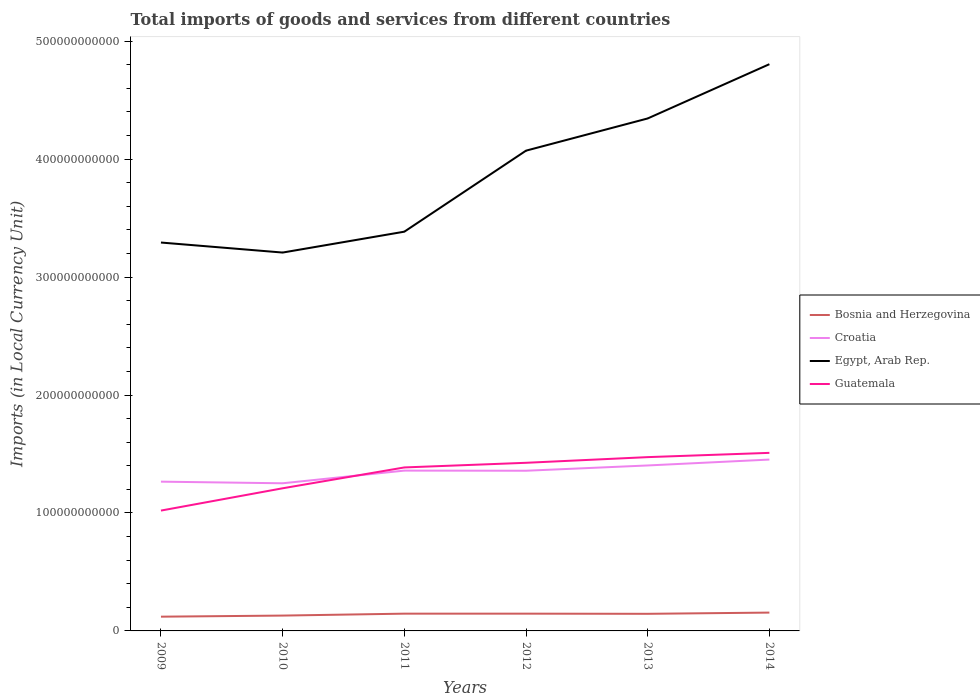How many different coloured lines are there?
Your answer should be compact. 4. Across all years, what is the maximum Amount of goods and services imports in Croatia?
Ensure brevity in your answer.  1.25e+11. In which year was the Amount of goods and services imports in Bosnia and Herzegovina maximum?
Make the answer very short. 2009. What is the total Amount of goods and services imports in Egypt, Arab Rep. in the graph?
Make the answer very short. -4.60e+1. What is the difference between the highest and the second highest Amount of goods and services imports in Bosnia and Herzegovina?
Ensure brevity in your answer.  3.45e+09. How many years are there in the graph?
Your answer should be compact. 6. What is the difference between two consecutive major ticks on the Y-axis?
Ensure brevity in your answer.  1.00e+11. Where does the legend appear in the graph?
Your response must be concise. Center right. How many legend labels are there?
Keep it short and to the point. 4. How are the legend labels stacked?
Provide a succinct answer. Vertical. What is the title of the graph?
Make the answer very short. Total imports of goods and services from different countries. Does "Czech Republic" appear as one of the legend labels in the graph?
Your response must be concise. No. What is the label or title of the X-axis?
Give a very brief answer. Years. What is the label or title of the Y-axis?
Your response must be concise. Imports (in Local Currency Unit). What is the Imports (in Local Currency Unit) of Bosnia and Herzegovina in 2009?
Make the answer very short. 1.21e+1. What is the Imports (in Local Currency Unit) of Croatia in 2009?
Give a very brief answer. 1.27e+11. What is the Imports (in Local Currency Unit) in Egypt, Arab Rep. in 2009?
Your response must be concise. 3.29e+11. What is the Imports (in Local Currency Unit) of Guatemala in 2009?
Your answer should be compact. 1.02e+11. What is the Imports (in Local Currency Unit) in Bosnia and Herzegovina in 2010?
Your answer should be very brief. 1.30e+1. What is the Imports (in Local Currency Unit) of Croatia in 2010?
Offer a terse response. 1.25e+11. What is the Imports (in Local Currency Unit) of Egypt, Arab Rep. in 2010?
Make the answer very short. 3.21e+11. What is the Imports (in Local Currency Unit) in Guatemala in 2010?
Provide a succinct answer. 1.21e+11. What is the Imports (in Local Currency Unit) in Bosnia and Herzegovina in 2011?
Your answer should be very brief. 1.46e+1. What is the Imports (in Local Currency Unit) in Croatia in 2011?
Keep it short and to the point. 1.36e+11. What is the Imports (in Local Currency Unit) of Egypt, Arab Rep. in 2011?
Your answer should be compact. 3.38e+11. What is the Imports (in Local Currency Unit) in Guatemala in 2011?
Provide a succinct answer. 1.39e+11. What is the Imports (in Local Currency Unit) in Bosnia and Herzegovina in 2012?
Your answer should be compact. 1.46e+1. What is the Imports (in Local Currency Unit) of Croatia in 2012?
Provide a succinct answer. 1.36e+11. What is the Imports (in Local Currency Unit) in Egypt, Arab Rep. in 2012?
Your answer should be very brief. 4.07e+11. What is the Imports (in Local Currency Unit) of Guatemala in 2012?
Provide a short and direct response. 1.43e+11. What is the Imports (in Local Currency Unit) of Bosnia and Herzegovina in 2013?
Your response must be concise. 1.45e+1. What is the Imports (in Local Currency Unit) of Croatia in 2013?
Provide a short and direct response. 1.40e+11. What is the Imports (in Local Currency Unit) of Egypt, Arab Rep. in 2013?
Keep it short and to the point. 4.34e+11. What is the Imports (in Local Currency Unit) in Guatemala in 2013?
Your answer should be very brief. 1.47e+11. What is the Imports (in Local Currency Unit) in Bosnia and Herzegovina in 2014?
Your answer should be very brief. 1.55e+1. What is the Imports (in Local Currency Unit) of Croatia in 2014?
Keep it short and to the point. 1.45e+11. What is the Imports (in Local Currency Unit) of Egypt, Arab Rep. in 2014?
Ensure brevity in your answer.  4.80e+11. What is the Imports (in Local Currency Unit) in Guatemala in 2014?
Provide a succinct answer. 1.51e+11. Across all years, what is the maximum Imports (in Local Currency Unit) of Bosnia and Herzegovina?
Offer a terse response. 1.55e+1. Across all years, what is the maximum Imports (in Local Currency Unit) of Croatia?
Your response must be concise. 1.45e+11. Across all years, what is the maximum Imports (in Local Currency Unit) of Egypt, Arab Rep.?
Ensure brevity in your answer.  4.80e+11. Across all years, what is the maximum Imports (in Local Currency Unit) of Guatemala?
Offer a terse response. 1.51e+11. Across all years, what is the minimum Imports (in Local Currency Unit) in Bosnia and Herzegovina?
Your answer should be compact. 1.21e+1. Across all years, what is the minimum Imports (in Local Currency Unit) in Croatia?
Give a very brief answer. 1.25e+11. Across all years, what is the minimum Imports (in Local Currency Unit) in Egypt, Arab Rep.?
Make the answer very short. 3.21e+11. Across all years, what is the minimum Imports (in Local Currency Unit) of Guatemala?
Make the answer very short. 1.02e+11. What is the total Imports (in Local Currency Unit) of Bosnia and Herzegovina in the graph?
Offer a very short reply. 8.44e+1. What is the total Imports (in Local Currency Unit) of Croatia in the graph?
Ensure brevity in your answer.  8.09e+11. What is the total Imports (in Local Currency Unit) in Egypt, Arab Rep. in the graph?
Give a very brief answer. 2.31e+12. What is the total Imports (in Local Currency Unit) in Guatemala in the graph?
Your response must be concise. 8.02e+11. What is the difference between the Imports (in Local Currency Unit) in Bosnia and Herzegovina in 2009 and that in 2010?
Ensure brevity in your answer.  -9.19e+08. What is the difference between the Imports (in Local Currency Unit) in Croatia in 2009 and that in 2010?
Provide a short and direct response. 1.38e+09. What is the difference between the Imports (in Local Currency Unit) of Egypt, Arab Rep. in 2009 and that in 2010?
Provide a short and direct response. 8.50e+09. What is the difference between the Imports (in Local Currency Unit) in Guatemala in 2009 and that in 2010?
Keep it short and to the point. -1.89e+1. What is the difference between the Imports (in Local Currency Unit) in Bosnia and Herzegovina in 2009 and that in 2011?
Provide a succinct answer. -2.55e+09. What is the difference between the Imports (in Local Currency Unit) of Croatia in 2009 and that in 2011?
Your answer should be compact. -9.36e+09. What is the difference between the Imports (in Local Currency Unit) of Egypt, Arab Rep. in 2009 and that in 2011?
Your response must be concise. -9.20e+09. What is the difference between the Imports (in Local Currency Unit) of Guatemala in 2009 and that in 2011?
Make the answer very short. -3.66e+1. What is the difference between the Imports (in Local Currency Unit) in Bosnia and Herzegovina in 2009 and that in 2012?
Offer a very short reply. -2.55e+09. What is the difference between the Imports (in Local Currency Unit) of Croatia in 2009 and that in 2012?
Provide a succinct answer. -9.27e+09. What is the difference between the Imports (in Local Currency Unit) of Egypt, Arab Rep. in 2009 and that in 2012?
Your response must be concise. -7.79e+1. What is the difference between the Imports (in Local Currency Unit) of Guatemala in 2009 and that in 2012?
Provide a succinct answer. -4.05e+1. What is the difference between the Imports (in Local Currency Unit) in Bosnia and Herzegovina in 2009 and that in 2013?
Provide a succinct answer. -2.42e+09. What is the difference between the Imports (in Local Currency Unit) in Croatia in 2009 and that in 2013?
Offer a very short reply. -1.37e+1. What is the difference between the Imports (in Local Currency Unit) of Egypt, Arab Rep. in 2009 and that in 2013?
Provide a succinct answer. -1.05e+11. What is the difference between the Imports (in Local Currency Unit) in Guatemala in 2009 and that in 2013?
Ensure brevity in your answer.  -4.53e+1. What is the difference between the Imports (in Local Currency Unit) of Bosnia and Herzegovina in 2009 and that in 2014?
Your answer should be very brief. -3.45e+09. What is the difference between the Imports (in Local Currency Unit) in Croatia in 2009 and that in 2014?
Give a very brief answer. -1.87e+1. What is the difference between the Imports (in Local Currency Unit) of Egypt, Arab Rep. in 2009 and that in 2014?
Provide a short and direct response. -1.51e+11. What is the difference between the Imports (in Local Currency Unit) of Guatemala in 2009 and that in 2014?
Make the answer very short. -4.89e+1. What is the difference between the Imports (in Local Currency Unit) of Bosnia and Herzegovina in 2010 and that in 2011?
Offer a terse response. -1.63e+09. What is the difference between the Imports (in Local Currency Unit) of Croatia in 2010 and that in 2011?
Your answer should be very brief. -1.07e+1. What is the difference between the Imports (in Local Currency Unit) of Egypt, Arab Rep. in 2010 and that in 2011?
Ensure brevity in your answer.  -1.77e+1. What is the difference between the Imports (in Local Currency Unit) of Guatemala in 2010 and that in 2011?
Your answer should be compact. -1.77e+1. What is the difference between the Imports (in Local Currency Unit) of Bosnia and Herzegovina in 2010 and that in 2012?
Ensure brevity in your answer.  -1.63e+09. What is the difference between the Imports (in Local Currency Unit) in Croatia in 2010 and that in 2012?
Offer a terse response. -1.06e+1. What is the difference between the Imports (in Local Currency Unit) in Egypt, Arab Rep. in 2010 and that in 2012?
Provide a succinct answer. -8.64e+1. What is the difference between the Imports (in Local Currency Unit) in Guatemala in 2010 and that in 2012?
Offer a very short reply. -2.16e+1. What is the difference between the Imports (in Local Currency Unit) of Bosnia and Herzegovina in 2010 and that in 2013?
Your answer should be compact. -1.50e+09. What is the difference between the Imports (in Local Currency Unit) of Croatia in 2010 and that in 2013?
Offer a very short reply. -1.51e+1. What is the difference between the Imports (in Local Currency Unit) of Egypt, Arab Rep. in 2010 and that in 2013?
Offer a terse response. -1.14e+11. What is the difference between the Imports (in Local Currency Unit) in Guatemala in 2010 and that in 2013?
Offer a terse response. -2.64e+1. What is the difference between the Imports (in Local Currency Unit) in Bosnia and Herzegovina in 2010 and that in 2014?
Provide a short and direct response. -2.53e+09. What is the difference between the Imports (in Local Currency Unit) of Croatia in 2010 and that in 2014?
Ensure brevity in your answer.  -2.01e+1. What is the difference between the Imports (in Local Currency Unit) of Egypt, Arab Rep. in 2010 and that in 2014?
Offer a terse response. -1.60e+11. What is the difference between the Imports (in Local Currency Unit) of Guatemala in 2010 and that in 2014?
Make the answer very short. -3.00e+1. What is the difference between the Imports (in Local Currency Unit) in Bosnia and Herzegovina in 2011 and that in 2012?
Provide a succinct answer. 1.75e+06. What is the difference between the Imports (in Local Currency Unit) of Croatia in 2011 and that in 2012?
Your response must be concise. 9.93e+07. What is the difference between the Imports (in Local Currency Unit) in Egypt, Arab Rep. in 2011 and that in 2012?
Keep it short and to the point. -6.87e+1. What is the difference between the Imports (in Local Currency Unit) of Guatemala in 2011 and that in 2012?
Offer a very short reply. -3.94e+09. What is the difference between the Imports (in Local Currency Unit) in Bosnia and Herzegovina in 2011 and that in 2013?
Your answer should be very brief. 1.36e+08. What is the difference between the Imports (in Local Currency Unit) of Croatia in 2011 and that in 2013?
Your answer should be very brief. -4.37e+09. What is the difference between the Imports (in Local Currency Unit) of Egypt, Arab Rep. in 2011 and that in 2013?
Your answer should be compact. -9.60e+1. What is the difference between the Imports (in Local Currency Unit) of Guatemala in 2011 and that in 2013?
Your response must be concise. -8.75e+09. What is the difference between the Imports (in Local Currency Unit) of Bosnia and Herzegovina in 2011 and that in 2014?
Offer a very short reply. -8.99e+08. What is the difference between the Imports (in Local Currency Unit) in Croatia in 2011 and that in 2014?
Offer a terse response. -9.36e+09. What is the difference between the Imports (in Local Currency Unit) of Egypt, Arab Rep. in 2011 and that in 2014?
Provide a short and direct response. -1.42e+11. What is the difference between the Imports (in Local Currency Unit) in Guatemala in 2011 and that in 2014?
Your answer should be compact. -1.24e+1. What is the difference between the Imports (in Local Currency Unit) in Bosnia and Herzegovina in 2012 and that in 2013?
Keep it short and to the point. 1.34e+08. What is the difference between the Imports (in Local Currency Unit) in Croatia in 2012 and that in 2013?
Provide a short and direct response. -4.47e+09. What is the difference between the Imports (in Local Currency Unit) of Egypt, Arab Rep. in 2012 and that in 2013?
Your response must be concise. -2.73e+1. What is the difference between the Imports (in Local Currency Unit) in Guatemala in 2012 and that in 2013?
Keep it short and to the point. -4.81e+09. What is the difference between the Imports (in Local Currency Unit) of Bosnia and Herzegovina in 2012 and that in 2014?
Give a very brief answer. -9.01e+08. What is the difference between the Imports (in Local Currency Unit) in Croatia in 2012 and that in 2014?
Ensure brevity in your answer.  -9.46e+09. What is the difference between the Imports (in Local Currency Unit) of Egypt, Arab Rep. in 2012 and that in 2014?
Make the answer very short. -7.33e+1. What is the difference between the Imports (in Local Currency Unit) of Guatemala in 2012 and that in 2014?
Ensure brevity in your answer.  -8.42e+09. What is the difference between the Imports (in Local Currency Unit) in Bosnia and Herzegovina in 2013 and that in 2014?
Give a very brief answer. -1.03e+09. What is the difference between the Imports (in Local Currency Unit) in Croatia in 2013 and that in 2014?
Make the answer very short. -5.00e+09. What is the difference between the Imports (in Local Currency Unit) of Egypt, Arab Rep. in 2013 and that in 2014?
Provide a succinct answer. -4.60e+1. What is the difference between the Imports (in Local Currency Unit) of Guatemala in 2013 and that in 2014?
Offer a very short reply. -3.61e+09. What is the difference between the Imports (in Local Currency Unit) of Bosnia and Herzegovina in 2009 and the Imports (in Local Currency Unit) of Croatia in 2010?
Your answer should be compact. -1.13e+11. What is the difference between the Imports (in Local Currency Unit) of Bosnia and Herzegovina in 2009 and the Imports (in Local Currency Unit) of Egypt, Arab Rep. in 2010?
Offer a terse response. -3.09e+11. What is the difference between the Imports (in Local Currency Unit) of Bosnia and Herzegovina in 2009 and the Imports (in Local Currency Unit) of Guatemala in 2010?
Provide a short and direct response. -1.09e+11. What is the difference between the Imports (in Local Currency Unit) of Croatia in 2009 and the Imports (in Local Currency Unit) of Egypt, Arab Rep. in 2010?
Provide a short and direct response. -1.94e+11. What is the difference between the Imports (in Local Currency Unit) in Croatia in 2009 and the Imports (in Local Currency Unit) in Guatemala in 2010?
Make the answer very short. 5.61e+09. What is the difference between the Imports (in Local Currency Unit) of Egypt, Arab Rep. in 2009 and the Imports (in Local Currency Unit) of Guatemala in 2010?
Keep it short and to the point. 2.08e+11. What is the difference between the Imports (in Local Currency Unit) of Bosnia and Herzegovina in 2009 and the Imports (in Local Currency Unit) of Croatia in 2011?
Your answer should be very brief. -1.24e+11. What is the difference between the Imports (in Local Currency Unit) in Bosnia and Herzegovina in 2009 and the Imports (in Local Currency Unit) in Egypt, Arab Rep. in 2011?
Your answer should be very brief. -3.26e+11. What is the difference between the Imports (in Local Currency Unit) of Bosnia and Herzegovina in 2009 and the Imports (in Local Currency Unit) of Guatemala in 2011?
Offer a terse response. -1.27e+11. What is the difference between the Imports (in Local Currency Unit) in Croatia in 2009 and the Imports (in Local Currency Unit) in Egypt, Arab Rep. in 2011?
Make the answer very short. -2.12e+11. What is the difference between the Imports (in Local Currency Unit) in Croatia in 2009 and the Imports (in Local Currency Unit) in Guatemala in 2011?
Your answer should be compact. -1.20e+1. What is the difference between the Imports (in Local Currency Unit) of Egypt, Arab Rep. in 2009 and the Imports (in Local Currency Unit) of Guatemala in 2011?
Offer a terse response. 1.91e+11. What is the difference between the Imports (in Local Currency Unit) of Bosnia and Herzegovina in 2009 and the Imports (in Local Currency Unit) of Croatia in 2012?
Make the answer very short. -1.24e+11. What is the difference between the Imports (in Local Currency Unit) in Bosnia and Herzegovina in 2009 and the Imports (in Local Currency Unit) in Egypt, Arab Rep. in 2012?
Your answer should be very brief. -3.95e+11. What is the difference between the Imports (in Local Currency Unit) in Bosnia and Herzegovina in 2009 and the Imports (in Local Currency Unit) in Guatemala in 2012?
Provide a short and direct response. -1.30e+11. What is the difference between the Imports (in Local Currency Unit) in Croatia in 2009 and the Imports (in Local Currency Unit) in Egypt, Arab Rep. in 2012?
Give a very brief answer. -2.81e+11. What is the difference between the Imports (in Local Currency Unit) of Croatia in 2009 and the Imports (in Local Currency Unit) of Guatemala in 2012?
Make the answer very short. -1.60e+1. What is the difference between the Imports (in Local Currency Unit) in Egypt, Arab Rep. in 2009 and the Imports (in Local Currency Unit) in Guatemala in 2012?
Your answer should be compact. 1.87e+11. What is the difference between the Imports (in Local Currency Unit) in Bosnia and Herzegovina in 2009 and the Imports (in Local Currency Unit) in Croatia in 2013?
Your response must be concise. -1.28e+11. What is the difference between the Imports (in Local Currency Unit) in Bosnia and Herzegovina in 2009 and the Imports (in Local Currency Unit) in Egypt, Arab Rep. in 2013?
Offer a terse response. -4.22e+11. What is the difference between the Imports (in Local Currency Unit) in Bosnia and Herzegovina in 2009 and the Imports (in Local Currency Unit) in Guatemala in 2013?
Your response must be concise. -1.35e+11. What is the difference between the Imports (in Local Currency Unit) of Croatia in 2009 and the Imports (in Local Currency Unit) of Egypt, Arab Rep. in 2013?
Offer a very short reply. -3.08e+11. What is the difference between the Imports (in Local Currency Unit) in Croatia in 2009 and the Imports (in Local Currency Unit) in Guatemala in 2013?
Keep it short and to the point. -2.08e+1. What is the difference between the Imports (in Local Currency Unit) in Egypt, Arab Rep. in 2009 and the Imports (in Local Currency Unit) in Guatemala in 2013?
Your response must be concise. 1.82e+11. What is the difference between the Imports (in Local Currency Unit) of Bosnia and Herzegovina in 2009 and the Imports (in Local Currency Unit) of Croatia in 2014?
Your response must be concise. -1.33e+11. What is the difference between the Imports (in Local Currency Unit) of Bosnia and Herzegovina in 2009 and the Imports (in Local Currency Unit) of Egypt, Arab Rep. in 2014?
Your answer should be very brief. -4.68e+11. What is the difference between the Imports (in Local Currency Unit) of Bosnia and Herzegovina in 2009 and the Imports (in Local Currency Unit) of Guatemala in 2014?
Make the answer very short. -1.39e+11. What is the difference between the Imports (in Local Currency Unit) in Croatia in 2009 and the Imports (in Local Currency Unit) in Egypt, Arab Rep. in 2014?
Offer a very short reply. -3.54e+11. What is the difference between the Imports (in Local Currency Unit) of Croatia in 2009 and the Imports (in Local Currency Unit) of Guatemala in 2014?
Keep it short and to the point. -2.44e+1. What is the difference between the Imports (in Local Currency Unit) in Egypt, Arab Rep. in 2009 and the Imports (in Local Currency Unit) in Guatemala in 2014?
Keep it short and to the point. 1.78e+11. What is the difference between the Imports (in Local Currency Unit) of Bosnia and Herzegovina in 2010 and the Imports (in Local Currency Unit) of Croatia in 2011?
Provide a short and direct response. -1.23e+11. What is the difference between the Imports (in Local Currency Unit) in Bosnia and Herzegovina in 2010 and the Imports (in Local Currency Unit) in Egypt, Arab Rep. in 2011?
Provide a short and direct response. -3.25e+11. What is the difference between the Imports (in Local Currency Unit) in Bosnia and Herzegovina in 2010 and the Imports (in Local Currency Unit) in Guatemala in 2011?
Keep it short and to the point. -1.26e+11. What is the difference between the Imports (in Local Currency Unit) in Croatia in 2010 and the Imports (in Local Currency Unit) in Egypt, Arab Rep. in 2011?
Provide a short and direct response. -2.13e+11. What is the difference between the Imports (in Local Currency Unit) in Croatia in 2010 and the Imports (in Local Currency Unit) in Guatemala in 2011?
Your answer should be very brief. -1.34e+1. What is the difference between the Imports (in Local Currency Unit) of Egypt, Arab Rep. in 2010 and the Imports (in Local Currency Unit) of Guatemala in 2011?
Offer a very short reply. 1.82e+11. What is the difference between the Imports (in Local Currency Unit) of Bosnia and Herzegovina in 2010 and the Imports (in Local Currency Unit) of Croatia in 2012?
Ensure brevity in your answer.  -1.23e+11. What is the difference between the Imports (in Local Currency Unit) of Bosnia and Herzegovina in 2010 and the Imports (in Local Currency Unit) of Egypt, Arab Rep. in 2012?
Ensure brevity in your answer.  -3.94e+11. What is the difference between the Imports (in Local Currency Unit) in Bosnia and Herzegovina in 2010 and the Imports (in Local Currency Unit) in Guatemala in 2012?
Offer a very short reply. -1.30e+11. What is the difference between the Imports (in Local Currency Unit) in Croatia in 2010 and the Imports (in Local Currency Unit) in Egypt, Arab Rep. in 2012?
Ensure brevity in your answer.  -2.82e+11. What is the difference between the Imports (in Local Currency Unit) of Croatia in 2010 and the Imports (in Local Currency Unit) of Guatemala in 2012?
Give a very brief answer. -1.74e+1. What is the difference between the Imports (in Local Currency Unit) of Egypt, Arab Rep. in 2010 and the Imports (in Local Currency Unit) of Guatemala in 2012?
Provide a short and direct response. 1.78e+11. What is the difference between the Imports (in Local Currency Unit) in Bosnia and Herzegovina in 2010 and the Imports (in Local Currency Unit) in Croatia in 2013?
Keep it short and to the point. -1.27e+11. What is the difference between the Imports (in Local Currency Unit) of Bosnia and Herzegovina in 2010 and the Imports (in Local Currency Unit) of Egypt, Arab Rep. in 2013?
Your answer should be very brief. -4.21e+11. What is the difference between the Imports (in Local Currency Unit) in Bosnia and Herzegovina in 2010 and the Imports (in Local Currency Unit) in Guatemala in 2013?
Make the answer very short. -1.34e+11. What is the difference between the Imports (in Local Currency Unit) in Croatia in 2010 and the Imports (in Local Currency Unit) in Egypt, Arab Rep. in 2013?
Provide a short and direct response. -3.09e+11. What is the difference between the Imports (in Local Currency Unit) of Croatia in 2010 and the Imports (in Local Currency Unit) of Guatemala in 2013?
Ensure brevity in your answer.  -2.22e+1. What is the difference between the Imports (in Local Currency Unit) of Egypt, Arab Rep. in 2010 and the Imports (in Local Currency Unit) of Guatemala in 2013?
Make the answer very short. 1.73e+11. What is the difference between the Imports (in Local Currency Unit) in Bosnia and Herzegovina in 2010 and the Imports (in Local Currency Unit) in Croatia in 2014?
Make the answer very short. -1.32e+11. What is the difference between the Imports (in Local Currency Unit) of Bosnia and Herzegovina in 2010 and the Imports (in Local Currency Unit) of Egypt, Arab Rep. in 2014?
Keep it short and to the point. -4.67e+11. What is the difference between the Imports (in Local Currency Unit) in Bosnia and Herzegovina in 2010 and the Imports (in Local Currency Unit) in Guatemala in 2014?
Give a very brief answer. -1.38e+11. What is the difference between the Imports (in Local Currency Unit) of Croatia in 2010 and the Imports (in Local Currency Unit) of Egypt, Arab Rep. in 2014?
Ensure brevity in your answer.  -3.55e+11. What is the difference between the Imports (in Local Currency Unit) in Croatia in 2010 and the Imports (in Local Currency Unit) in Guatemala in 2014?
Offer a very short reply. -2.58e+1. What is the difference between the Imports (in Local Currency Unit) in Egypt, Arab Rep. in 2010 and the Imports (in Local Currency Unit) in Guatemala in 2014?
Your response must be concise. 1.70e+11. What is the difference between the Imports (in Local Currency Unit) in Bosnia and Herzegovina in 2011 and the Imports (in Local Currency Unit) in Croatia in 2012?
Provide a succinct answer. -1.21e+11. What is the difference between the Imports (in Local Currency Unit) in Bosnia and Herzegovina in 2011 and the Imports (in Local Currency Unit) in Egypt, Arab Rep. in 2012?
Make the answer very short. -3.93e+11. What is the difference between the Imports (in Local Currency Unit) in Bosnia and Herzegovina in 2011 and the Imports (in Local Currency Unit) in Guatemala in 2012?
Make the answer very short. -1.28e+11. What is the difference between the Imports (in Local Currency Unit) of Croatia in 2011 and the Imports (in Local Currency Unit) of Egypt, Arab Rep. in 2012?
Your answer should be very brief. -2.71e+11. What is the difference between the Imports (in Local Currency Unit) in Croatia in 2011 and the Imports (in Local Currency Unit) in Guatemala in 2012?
Your answer should be compact. -6.63e+09. What is the difference between the Imports (in Local Currency Unit) of Egypt, Arab Rep. in 2011 and the Imports (in Local Currency Unit) of Guatemala in 2012?
Keep it short and to the point. 1.96e+11. What is the difference between the Imports (in Local Currency Unit) of Bosnia and Herzegovina in 2011 and the Imports (in Local Currency Unit) of Croatia in 2013?
Keep it short and to the point. -1.26e+11. What is the difference between the Imports (in Local Currency Unit) of Bosnia and Herzegovina in 2011 and the Imports (in Local Currency Unit) of Egypt, Arab Rep. in 2013?
Ensure brevity in your answer.  -4.20e+11. What is the difference between the Imports (in Local Currency Unit) in Bosnia and Herzegovina in 2011 and the Imports (in Local Currency Unit) in Guatemala in 2013?
Your response must be concise. -1.33e+11. What is the difference between the Imports (in Local Currency Unit) in Croatia in 2011 and the Imports (in Local Currency Unit) in Egypt, Arab Rep. in 2013?
Ensure brevity in your answer.  -2.99e+11. What is the difference between the Imports (in Local Currency Unit) in Croatia in 2011 and the Imports (in Local Currency Unit) in Guatemala in 2013?
Keep it short and to the point. -1.14e+1. What is the difference between the Imports (in Local Currency Unit) of Egypt, Arab Rep. in 2011 and the Imports (in Local Currency Unit) of Guatemala in 2013?
Your answer should be compact. 1.91e+11. What is the difference between the Imports (in Local Currency Unit) of Bosnia and Herzegovina in 2011 and the Imports (in Local Currency Unit) of Croatia in 2014?
Your response must be concise. -1.31e+11. What is the difference between the Imports (in Local Currency Unit) in Bosnia and Herzegovina in 2011 and the Imports (in Local Currency Unit) in Egypt, Arab Rep. in 2014?
Offer a terse response. -4.66e+11. What is the difference between the Imports (in Local Currency Unit) in Bosnia and Herzegovina in 2011 and the Imports (in Local Currency Unit) in Guatemala in 2014?
Provide a succinct answer. -1.36e+11. What is the difference between the Imports (in Local Currency Unit) of Croatia in 2011 and the Imports (in Local Currency Unit) of Egypt, Arab Rep. in 2014?
Your answer should be compact. -3.45e+11. What is the difference between the Imports (in Local Currency Unit) of Croatia in 2011 and the Imports (in Local Currency Unit) of Guatemala in 2014?
Offer a terse response. -1.50e+1. What is the difference between the Imports (in Local Currency Unit) of Egypt, Arab Rep. in 2011 and the Imports (in Local Currency Unit) of Guatemala in 2014?
Your answer should be compact. 1.88e+11. What is the difference between the Imports (in Local Currency Unit) of Bosnia and Herzegovina in 2012 and the Imports (in Local Currency Unit) of Croatia in 2013?
Keep it short and to the point. -1.26e+11. What is the difference between the Imports (in Local Currency Unit) in Bosnia and Herzegovina in 2012 and the Imports (in Local Currency Unit) in Egypt, Arab Rep. in 2013?
Your response must be concise. -4.20e+11. What is the difference between the Imports (in Local Currency Unit) in Bosnia and Herzegovina in 2012 and the Imports (in Local Currency Unit) in Guatemala in 2013?
Your response must be concise. -1.33e+11. What is the difference between the Imports (in Local Currency Unit) in Croatia in 2012 and the Imports (in Local Currency Unit) in Egypt, Arab Rep. in 2013?
Make the answer very short. -2.99e+11. What is the difference between the Imports (in Local Currency Unit) of Croatia in 2012 and the Imports (in Local Currency Unit) of Guatemala in 2013?
Make the answer very short. -1.15e+1. What is the difference between the Imports (in Local Currency Unit) of Egypt, Arab Rep. in 2012 and the Imports (in Local Currency Unit) of Guatemala in 2013?
Provide a short and direct response. 2.60e+11. What is the difference between the Imports (in Local Currency Unit) in Bosnia and Herzegovina in 2012 and the Imports (in Local Currency Unit) in Croatia in 2014?
Your response must be concise. -1.31e+11. What is the difference between the Imports (in Local Currency Unit) of Bosnia and Herzegovina in 2012 and the Imports (in Local Currency Unit) of Egypt, Arab Rep. in 2014?
Your answer should be very brief. -4.66e+11. What is the difference between the Imports (in Local Currency Unit) in Bosnia and Herzegovina in 2012 and the Imports (in Local Currency Unit) in Guatemala in 2014?
Give a very brief answer. -1.36e+11. What is the difference between the Imports (in Local Currency Unit) of Croatia in 2012 and the Imports (in Local Currency Unit) of Egypt, Arab Rep. in 2014?
Provide a short and direct response. -3.45e+11. What is the difference between the Imports (in Local Currency Unit) of Croatia in 2012 and the Imports (in Local Currency Unit) of Guatemala in 2014?
Give a very brief answer. -1.51e+1. What is the difference between the Imports (in Local Currency Unit) of Egypt, Arab Rep. in 2012 and the Imports (in Local Currency Unit) of Guatemala in 2014?
Offer a terse response. 2.56e+11. What is the difference between the Imports (in Local Currency Unit) in Bosnia and Herzegovina in 2013 and the Imports (in Local Currency Unit) in Croatia in 2014?
Keep it short and to the point. -1.31e+11. What is the difference between the Imports (in Local Currency Unit) in Bosnia and Herzegovina in 2013 and the Imports (in Local Currency Unit) in Egypt, Arab Rep. in 2014?
Your response must be concise. -4.66e+11. What is the difference between the Imports (in Local Currency Unit) of Bosnia and Herzegovina in 2013 and the Imports (in Local Currency Unit) of Guatemala in 2014?
Keep it short and to the point. -1.36e+11. What is the difference between the Imports (in Local Currency Unit) of Croatia in 2013 and the Imports (in Local Currency Unit) of Egypt, Arab Rep. in 2014?
Give a very brief answer. -3.40e+11. What is the difference between the Imports (in Local Currency Unit) in Croatia in 2013 and the Imports (in Local Currency Unit) in Guatemala in 2014?
Keep it short and to the point. -1.07e+1. What is the difference between the Imports (in Local Currency Unit) of Egypt, Arab Rep. in 2013 and the Imports (in Local Currency Unit) of Guatemala in 2014?
Make the answer very short. 2.84e+11. What is the average Imports (in Local Currency Unit) of Bosnia and Herzegovina per year?
Provide a succinct answer. 1.41e+1. What is the average Imports (in Local Currency Unit) in Croatia per year?
Provide a short and direct response. 1.35e+11. What is the average Imports (in Local Currency Unit) of Egypt, Arab Rep. per year?
Your answer should be very brief. 3.85e+11. What is the average Imports (in Local Currency Unit) in Guatemala per year?
Make the answer very short. 1.34e+11. In the year 2009, what is the difference between the Imports (in Local Currency Unit) of Bosnia and Herzegovina and Imports (in Local Currency Unit) of Croatia?
Make the answer very short. -1.14e+11. In the year 2009, what is the difference between the Imports (in Local Currency Unit) of Bosnia and Herzegovina and Imports (in Local Currency Unit) of Egypt, Arab Rep.?
Offer a terse response. -3.17e+11. In the year 2009, what is the difference between the Imports (in Local Currency Unit) of Bosnia and Herzegovina and Imports (in Local Currency Unit) of Guatemala?
Provide a succinct answer. -8.99e+1. In the year 2009, what is the difference between the Imports (in Local Currency Unit) of Croatia and Imports (in Local Currency Unit) of Egypt, Arab Rep.?
Your answer should be very brief. -2.03e+11. In the year 2009, what is the difference between the Imports (in Local Currency Unit) of Croatia and Imports (in Local Currency Unit) of Guatemala?
Provide a succinct answer. 2.45e+1. In the year 2009, what is the difference between the Imports (in Local Currency Unit) in Egypt, Arab Rep. and Imports (in Local Currency Unit) in Guatemala?
Keep it short and to the point. 2.27e+11. In the year 2010, what is the difference between the Imports (in Local Currency Unit) in Bosnia and Herzegovina and Imports (in Local Currency Unit) in Croatia?
Ensure brevity in your answer.  -1.12e+11. In the year 2010, what is the difference between the Imports (in Local Currency Unit) in Bosnia and Herzegovina and Imports (in Local Currency Unit) in Egypt, Arab Rep.?
Your answer should be compact. -3.08e+11. In the year 2010, what is the difference between the Imports (in Local Currency Unit) of Bosnia and Herzegovina and Imports (in Local Currency Unit) of Guatemala?
Offer a terse response. -1.08e+11. In the year 2010, what is the difference between the Imports (in Local Currency Unit) in Croatia and Imports (in Local Currency Unit) in Egypt, Arab Rep.?
Offer a terse response. -1.96e+11. In the year 2010, what is the difference between the Imports (in Local Currency Unit) of Croatia and Imports (in Local Currency Unit) of Guatemala?
Provide a succinct answer. 4.24e+09. In the year 2010, what is the difference between the Imports (in Local Currency Unit) of Egypt, Arab Rep. and Imports (in Local Currency Unit) of Guatemala?
Provide a succinct answer. 2.00e+11. In the year 2011, what is the difference between the Imports (in Local Currency Unit) of Bosnia and Herzegovina and Imports (in Local Currency Unit) of Croatia?
Make the answer very short. -1.21e+11. In the year 2011, what is the difference between the Imports (in Local Currency Unit) in Bosnia and Herzegovina and Imports (in Local Currency Unit) in Egypt, Arab Rep.?
Give a very brief answer. -3.24e+11. In the year 2011, what is the difference between the Imports (in Local Currency Unit) of Bosnia and Herzegovina and Imports (in Local Currency Unit) of Guatemala?
Offer a terse response. -1.24e+11. In the year 2011, what is the difference between the Imports (in Local Currency Unit) in Croatia and Imports (in Local Currency Unit) in Egypt, Arab Rep.?
Make the answer very short. -2.03e+11. In the year 2011, what is the difference between the Imports (in Local Currency Unit) of Croatia and Imports (in Local Currency Unit) of Guatemala?
Provide a short and direct response. -2.68e+09. In the year 2011, what is the difference between the Imports (in Local Currency Unit) of Egypt, Arab Rep. and Imports (in Local Currency Unit) of Guatemala?
Give a very brief answer. 2.00e+11. In the year 2012, what is the difference between the Imports (in Local Currency Unit) in Bosnia and Herzegovina and Imports (in Local Currency Unit) in Croatia?
Your response must be concise. -1.21e+11. In the year 2012, what is the difference between the Imports (in Local Currency Unit) of Bosnia and Herzegovina and Imports (in Local Currency Unit) of Egypt, Arab Rep.?
Make the answer very short. -3.93e+11. In the year 2012, what is the difference between the Imports (in Local Currency Unit) of Bosnia and Herzegovina and Imports (in Local Currency Unit) of Guatemala?
Offer a terse response. -1.28e+11. In the year 2012, what is the difference between the Imports (in Local Currency Unit) in Croatia and Imports (in Local Currency Unit) in Egypt, Arab Rep.?
Give a very brief answer. -2.71e+11. In the year 2012, what is the difference between the Imports (in Local Currency Unit) of Croatia and Imports (in Local Currency Unit) of Guatemala?
Your answer should be very brief. -6.73e+09. In the year 2012, what is the difference between the Imports (in Local Currency Unit) in Egypt, Arab Rep. and Imports (in Local Currency Unit) in Guatemala?
Make the answer very short. 2.65e+11. In the year 2013, what is the difference between the Imports (in Local Currency Unit) in Bosnia and Herzegovina and Imports (in Local Currency Unit) in Croatia?
Keep it short and to the point. -1.26e+11. In the year 2013, what is the difference between the Imports (in Local Currency Unit) of Bosnia and Herzegovina and Imports (in Local Currency Unit) of Egypt, Arab Rep.?
Give a very brief answer. -4.20e+11. In the year 2013, what is the difference between the Imports (in Local Currency Unit) in Bosnia and Herzegovina and Imports (in Local Currency Unit) in Guatemala?
Keep it short and to the point. -1.33e+11. In the year 2013, what is the difference between the Imports (in Local Currency Unit) in Croatia and Imports (in Local Currency Unit) in Egypt, Arab Rep.?
Your answer should be compact. -2.94e+11. In the year 2013, what is the difference between the Imports (in Local Currency Unit) in Croatia and Imports (in Local Currency Unit) in Guatemala?
Your answer should be compact. -7.07e+09. In the year 2013, what is the difference between the Imports (in Local Currency Unit) in Egypt, Arab Rep. and Imports (in Local Currency Unit) in Guatemala?
Give a very brief answer. 2.87e+11. In the year 2014, what is the difference between the Imports (in Local Currency Unit) in Bosnia and Herzegovina and Imports (in Local Currency Unit) in Croatia?
Provide a succinct answer. -1.30e+11. In the year 2014, what is the difference between the Imports (in Local Currency Unit) of Bosnia and Herzegovina and Imports (in Local Currency Unit) of Egypt, Arab Rep.?
Give a very brief answer. -4.65e+11. In the year 2014, what is the difference between the Imports (in Local Currency Unit) in Bosnia and Herzegovina and Imports (in Local Currency Unit) in Guatemala?
Your answer should be compact. -1.35e+11. In the year 2014, what is the difference between the Imports (in Local Currency Unit) of Croatia and Imports (in Local Currency Unit) of Egypt, Arab Rep.?
Your response must be concise. -3.35e+11. In the year 2014, what is the difference between the Imports (in Local Currency Unit) in Croatia and Imports (in Local Currency Unit) in Guatemala?
Provide a short and direct response. -5.68e+09. In the year 2014, what is the difference between the Imports (in Local Currency Unit) of Egypt, Arab Rep. and Imports (in Local Currency Unit) of Guatemala?
Ensure brevity in your answer.  3.30e+11. What is the ratio of the Imports (in Local Currency Unit) of Bosnia and Herzegovina in 2009 to that in 2010?
Keep it short and to the point. 0.93. What is the ratio of the Imports (in Local Currency Unit) of Croatia in 2009 to that in 2010?
Keep it short and to the point. 1.01. What is the ratio of the Imports (in Local Currency Unit) in Egypt, Arab Rep. in 2009 to that in 2010?
Your answer should be very brief. 1.03. What is the ratio of the Imports (in Local Currency Unit) of Guatemala in 2009 to that in 2010?
Offer a terse response. 0.84. What is the ratio of the Imports (in Local Currency Unit) in Bosnia and Herzegovina in 2009 to that in 2011?
Your answer should be very brief. 0.83. What is the ratio of the Imports (in Local Currency Unit) in Croatia in 2009 to that in 2011?
Your response must be concise. 0.93. What is the ratio of the Imports (in Local Currency Unit) in Egypt, Arab Rep. in 2009 to that in 2011?
Offer a terse response. 0.97. What is the ratio of the Imports (in Local Currency Unit) of Guatemala in 2009 to that in 2011?
Keep it short and to the point. 0.74. What is the ratio of the Imports (in Local Currency Unit) of Bosnia and Herzegovina in 2009 to that in 2012?
Offer a very short reply. 0.83. What is the ratio of the Imports (in Local Currency Unit) of Croatia in 2009 to that in 2012?
Your answer should be compact. 0.93. What is the ratio of the Imports (in Local Currency Unit) of Egypt, Arab Rep. in 2009 to that in 2012?
Your answer should be compact. 0.81. What is the ratio of the Imports (in Local Currency Unit) in Guatemala in 2009 to that in 2012?
Your answer should be very brief. 0.72. What is the ratio of the Imports (in Local Currency Unit) in Bosnia and Herzegovina in 2009 to that in 2013?
Make the answer very short. 0.83. What is the ratio of the Imports (in Local Currency Unit) in Croatia in 2009 to that in 2013?
Provide a succinct answer. 0.9. What is the ratio of the Imports (in Local Currency Unit) in Egypt, Arab Rep. in 2009 to that in 2013?
Give a very brief answer. 0.76. What is the ratio of the Imports (in Local Currency Unit) of Guatemala in 2009 to that in 2013?
Ensure brevity in your answer.  0.69. What is the ratio of the Imports (in Local Currency Unit) in Bosnia and Herzegovina in 2009 to that in 2014?
Ensure brevity in your answer.  0.78. What is the ratio of the Imports (in Local Currency Unit) of Croatia in 2009 to that in 2014?
Give a very brief answer. 0.87. What is the ratio of the Imports (in Local Currency Unit) of Egypt, Arab Rep. in 2009 to that in 2014?
Provide a succinct answer. 0.69. What is the ratio of the Imports (in Local Currency Unit) of Guatemala in 2009 to that in 2014?
Offer a very short reply. 0.68. What is the ratio of the Imports (in Local Currency Unit) in Bosnia and Herzegovina in 2010 to that in 2011?
Provide a short and direct response. 0.89. What is the ratio of the Imports (in Local Currency Unit) in Croatia in 2010 to that in 2011?
Keep it short and to the point. 0.92. What is the ratio of the Imports (in Local Currency Unit) in Egypt, Arab Rep. in 2010 to that in 2011?
Offer a terse response. 0.95. What is the ratio of the Imports (in Local Currency Unit) in Guatemala in 2010 to that in 2011?
Provide a succinct answer. 0.87. What is the ratio of the Imports (in Local Currency Unit) in Bosnia and Herzegovina in 2010 to that in 2012?
Ensure brevity in your answer.  0.89. What is the ratio of the Imports (in Local Currency Unit) of Croatia in 2010 to that in 2012?
Your response must be concise. 0.92. What is the ratio of the Imports (in Local Currency Unit) of Egypt, Arab Rep. in 2010 to that in 2012?
Ensure brevity in your answer.  0.79. What is the ratio of the Imports (in Local Currency Unit) in Guatemala in 2010 to that in 2012?
Your answer should be compact. 0.85. What is the ratio of the Imports (in Local Currency Unit) in Bosnia and Herzegovina in 2010 to that in 2013?
Make the answer very short. 0.9. What is the ratio of the Imports (in Local Currency Unit) in Croatia in 2010 to that in 2013?
Offer a very short reply. 0.89. What is the ratio of the Imports (in Local Currency Unit) in Egypt, Arab Rep. in 2010 to that in 2013?
Provide a succinct answer. 0.74. What is the ratio of the Imports (in Local Currency Unit) in Guatemala in 2010 to that in 2013?
Your response must be concise. 0.82. What is the ratio of the Imports (in Local Currency Unit) in Bosnia and Herzegovina in 2010 to that in 2014?
Your response must be concise. 0.84. What is the ratio of the Imports (in Local Currency Unit) of Croatia in 2010 to that in 2014?
Offer a very short reply. 0.86. What is the ratio of the Imports (in Local Currency Unit) in Egypt, Arab Rep. in 2010 to that in 2014?
Make the answer very short. 0.67. What is the ratio of the Imports (in Local Currency Unit) in Guatemala in 2010 to that in 2014?
Your answer should be very brief. 0.8. What is the ratio of the Imports (in Local Currency Unit) in Croatia in 2011 to that in 2012?
Provide a short and direct response. 1. What is the ratio of the Imports (in Local Currency Unit) in Egypt, Arab Rep. in 2011 to that in 2012?
Give a very brief answer. 0.83. What is the ratio of the Imports (in Local Currency Unit) of Guatemala in 2011 to that in 2012?
Your answer should be compact. 0.97. What is the ratio of the Imports (in Local Currency Unit) in Bosnia and Herzegovina in 2011 to that in 2013?
Keep it short and to the point. 1.01. What is the ratio of the Imports (in Local Currency Unit) in Croatia in 2011 to that in 2013?
Offer a terse response. 0.97. What is the ratio of the Imports (in Local Currency Unit) in Egypt, Arab Rep. in 2011 to that in 2013?
Keep it short and to the point. 0.78. What is the ratio of the Imports (in Local Currency Unit) in Guatemala in 2011 to that in 2013?
Your answer should be compact. 0.94. What is the ratio of the Imports (in Local Currency Unit) in Bosnia and Herzegovina in 2011 to that in 2014?
Make the answer very short. 0.94. What is the ratio of the Imports (in Local Currency Unit) in Croatia in 2011 to that in 2014?
Ensure brevity in your answer.  0.94. What is the ratio of the Imports (in Local Currency Unit) of Egypt, Arab Rep. in 2011 to that in 2014?
Your response must be concise. 0.7. What is the ratio of the Imports (in Local Currency Unit) of Guatemala in 2011 to that in 2014?
Your answer should be compact. 0.92. What is the ratio of the Imports (in Local Currency Unit) in Bosnia and Herzegovina in 2012 to that in 2013?
Offer a terse response. 1.01. What is the ratio of the Imports (in Local Currency Unit) in Croatia in 2012 to that in 2013?
Your response must be concise. 0.97. What is the ratio of the Imports (in Local Currency Unit) in Egypt, Arab Rep. in 2012 to that in 2013?
Provide a succinct answer. 0.94. What is the ratio of the Imports (in Local Currency Unit) of Guatemala in 2012 to that in 2013?
Keep it short and to the point. 0.97. What is the ratio of the Imports (in Local Currency Unit) of Bosnia and Herzegovina in 2012 to that in 2014?
Your answer should be very brief. 0.94. What is the ratio of the Imports (in Local Currency Unit) in Croatia in 2012 to that in 2014?
Provide a succinct answer. 0.93. What is the ratio of the Imports (in Local Currency Unit) of Egypt, Arab Rep. in 2012 to that in 2014?
Offer a terse response. 0.85. What is the ratio of the Imports (in Local Currency Unit) in Guatemala in 2012 to that in 2014?
Your answer should be compact. 0.94. What is the ratio of the Imports (in Local Currency Unit) in Bosnia and Herzegovina in 2013 to that in 2014?
Your answer should be compact. 0.93. What is the ratio of the Imports (in Local Currency Unit) in Croatia in 2013 to that in 2014?
Your answer should be compact. 0.97. What is the ratio of the Imports (in Local Currency Unit) in Egypt, Arab Rep. in 2013 to that in 2014?
Ensure brevity in your answer.  0.9. What is the ratio of the Imports (in Local Currency Unit) in Guatemala in 2013 to that in 2014?
Your answer should be very brief. 0.98. What is the difference between the highest and the second highest Imports (in Local Currency Unit) of Bosnia and Herzegovina?
Offer a terse response. 8.99e+08. What is the difference between the highest and the second highest Imports (in Local Currency Unit) in Croatia?
Provide a short and direct response. 5.00e+09. What is the difference between the highest and the second highest Imports (in Local Currency Unit) in Egypt, Arab Rep.?
Give a very brief answer. 4.60e+1. What is the difference between the highest and the second highest Imports (in Local Currency Unit) in Guatemala?
Offer a terse response. 3.61e+09. What is the difference between the highest and the lowest Imports (in Local Currency Unit) in Bosnia and Herzegovina?
Give a very brief answer. 3.45e+09. What is the difference between the highest and the lowest Imports (in Local Currency Unit) of Croatia?
Ensure brevity in your answer.  2.01e+1. What is the difference between the highest and the lowest Imports (in Local Currency Unit) of Egypt, Arab Rep.?
Your answer should be very brief. 1.60e+11. What is the difference between the highest and the lowest Imports (in Local Currency Unit) in Guatemala?
Provide a short and direct response. 4.89e+1. 